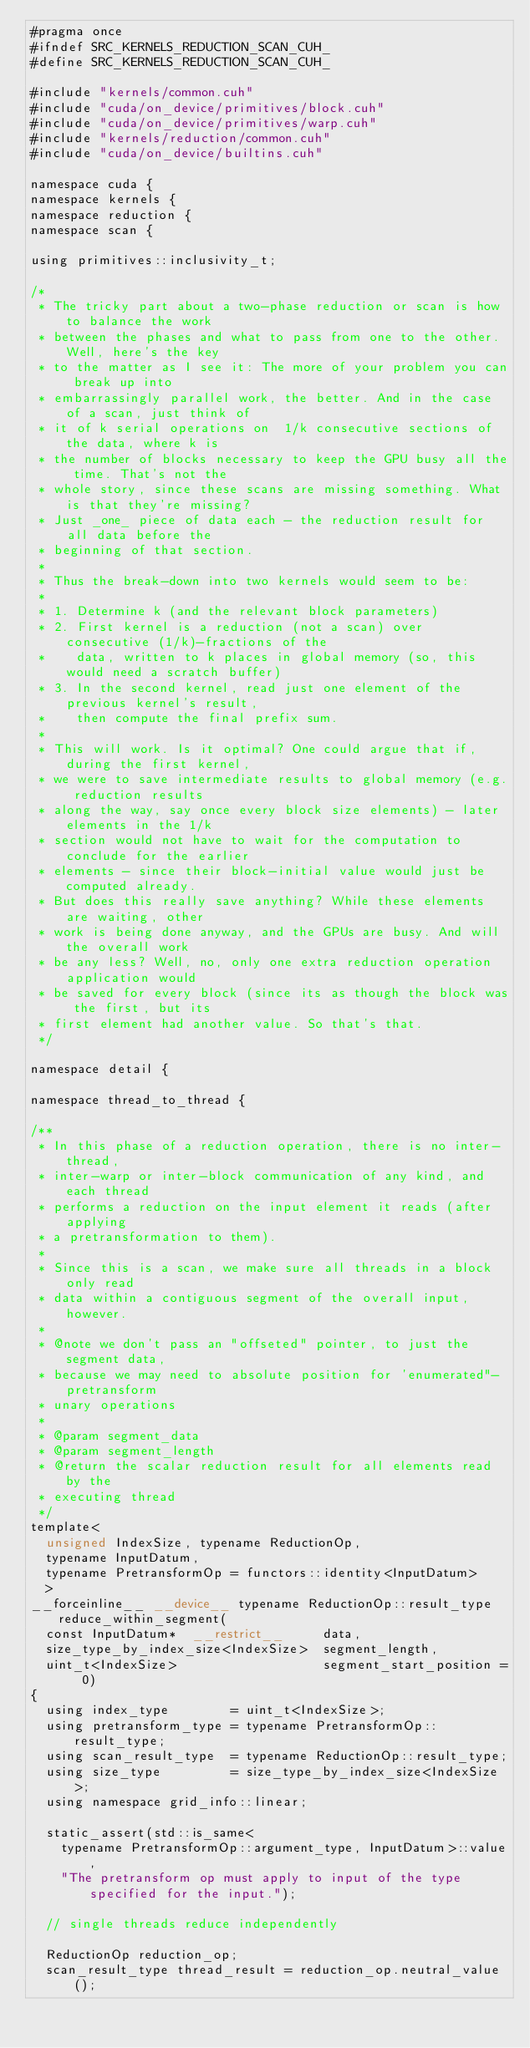<code> <loc_0><loc_0><loc_500><loc_500><_Cuda_>#pragma once
#ifndef SRC_KERNELS_REDUCTION_SCAN_CUH_
#define SRC_KERNELS_REDUCTION_SCAN_CUH_

#include "kernels/common.cuh"
#include "cuda/on_device/primitives/block.cuh"
#include "cuda/on_device/primitives/warp.cuh"
#include "kernels/reduction/common.cuh"
#include "cuda/on_device/builtins.cuh"

namespace cuda {
namespace kernels {
namespace reduction {
namespace scan {

using primitives::inclusivity_t;

/*
 * The tricky part about a two-phase reduction or scan is how to balance the work
 * between the phases and what to pass from one to the other. Well, here's the key
 * to the matter as I see it: The more of your problem you can break up into
 * embarrassingly parallel work, the better. And in the case of a scan, just think of
 * it of k serial operations on  1/k consecutive sections of the data, where k is
 * the number of blocks necessary to keep the GPU busy all the time. That's not the
 * whole story, since these scans are missing something. What is that they're missing?
 * Just _one_ piece of data each - the reduction result for all data before the
 * beginning of that section.
 *
 * Thus the break-down into two kernels would seem to be:
 *
 * 1. Determine k (and the relevant block parameters)
 * 2. First kernel is a reduction (not a scan) over consecutive (1/k)-fractions of the
 *    data, written to k places in global memory (so, this would need a scratch buffer)
 * 3. In the second kernel, read just one element of the previous kernel's result,
 *    then compute the final prefix sum.
 *
 * This will work. Is it optimal? One could argue that if, during the first kernel,
 * we were to save intermediate results to global memory (e.g. reduction results
 * along the way, say once every block size elements) - later elements in the 1/k
 * section would not have to wait for the computation to conclude for the earlier
 * elements - since their block-initial value would just be computed already.
 * But does this really save anything? While these elements are waiting, other
 * work is being done anyway, and the GPUs are busy. And will the overall work
 * be any less? Well, no, only one extra reduction operation application would
 * be saved for every block (since its as though the block was the first, but its
 * first element had another value. So that's that.
 */

namespace detail {

namespace thread_to_thread {

/**
 * In this phase of a reduction operation, there is no inter-thread,
 * inter-warp or inter-block communication of any kind, and each thread
 * performs a reduction on the input element it reads (after applying
 * a pretransformation to them).
 *
 * Since this is a scan, we make sure all threads in a block only read
 * data within a contiguous segment of the overall input, however.
 *
 * @note we don't pass an "offseted" pointer, to just the segment data,
 * because we may need to absolute position for 'enumerated"-pretransform
 * unary operations
 *
 * @param segment_data
 * @param segment_length
 * @return the scalar reduction result for all elements read by the
 * executing thread
 */
template<
	unsigned IndexSize, typename ReductionOp,
	typename InputDatum,
	typename PretransformOp = functors::identity<InputDatum>
	>
__forceinline__ __device__ typename ReductionOp::result_type reduce_within_segment(
	const InputDatum*  __restrict__     data,
	size_type_by_index_size<IndexSize>  segment_length,
	uint_t<IndexSize>                   segment_start_position = 0)
{
	using index_type        = uint_t<IndexSize>;
	using pretransform_type = typename PretransformOp::result_type;
	using scan_result_type  = typename ReductionOp::result_type;
	using size_type         = size_type_by_index_size<IndexSize>;
	using namespace grid_info::linear;

	static_assert(std::is_same<
		typename PretransformOp::argument_type, InputDatum>::value,
		"The pretransform op must apply to input of the type specified for the input.");

	// single threads reduce independently

	ReductionOp reduction_op;
	scan_result_type thread_result = reduction_op.neutral_value();
</code> 